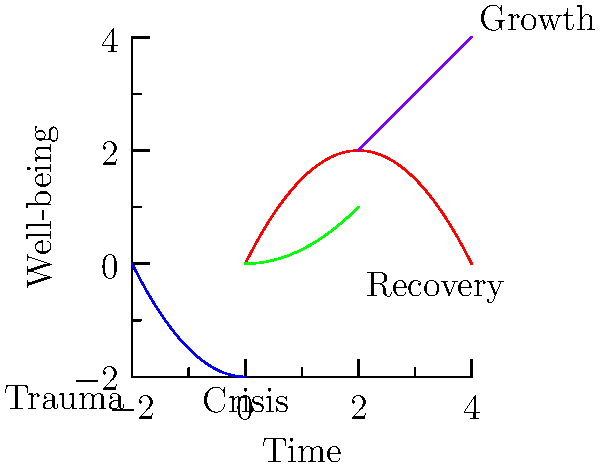In the image depicting stages of post-traumatic growth and recovery, which stage is represented by the green curve? The graph shows four distinct stages in the process of post-traumatic growth and recovery:

1. The blue curve represents the initial trauma, showing a steep decline in well-being.
2. The red curve represents the crisis stage, where well-being starts to improve but fluctuates.
3. The green curve shows a gradual upward trend, representing the recovery stage.
4. The purple line shows a steeper upward trend, representing continued growth.

The green curve, which is the third stage in the sequence, represents the recovery phase. During this stage, the individual begins to show consistent improvement in well-being, albeit at a slower rate compared to the final growth stage.
Answer: Recovery 